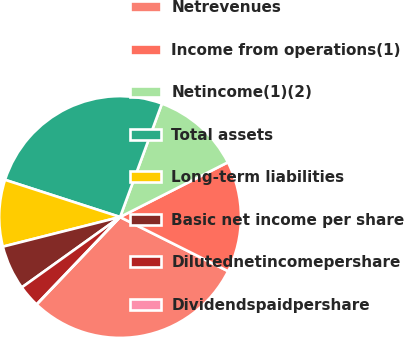<chart> <loc_0><loc_0><loc_500><loc_500><pie_chart><fcel>Netrevenues<fcel>Income from operations(1)<fcel>Netincome(1)(2)<fcel>Total assets<fcel>Long-term liabilities<fcel>Basic net income per share<fcel>Dilutednetincomepershare<fcel>Dividendspaidpershare<nl><fcel>29.74%<fcel>14.87%<fcel>11.9%<fcel>25.65%<fcel>8.92%<fcel>5.95%<fcel>2.97%<fcel>0.0%<nl></chart> 